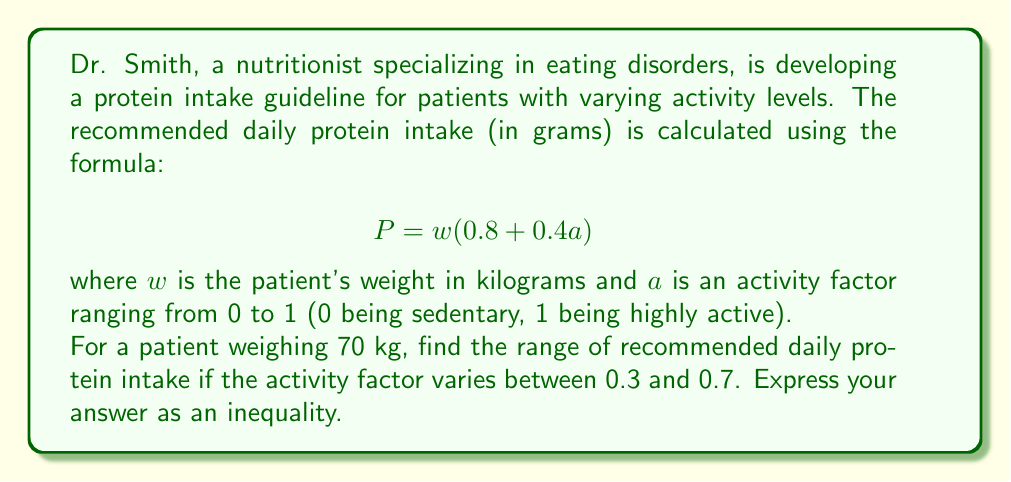Teach me how to tackle this problem. To solve this problem, we need to:

1. Substitute the given values into the formula for both the lower and upper bounds of the activity factor.
2. Calculate the protein intake for both cases.
3. Express the result as an inequality.

For the lower bound (a = 0.3):
$$ P_{low} = 70(0.8 + 0.4(0.3)) $$
$$ P_{low} = 70(0.8 + 0.12) $$
$$ P_{low} = 70(0.92) = 64.4 \text{ grams} $$

For the upper bound (a = 0.7):
$$ P_{high} = 70(0.8 + 0.4(0.7)) $$
$$ P_{high} = 70(0.8 + 0.28) $$
$$ P_{high} = 70(1.08) = 75.6 \text{ grams} $$

Therefore, the range of recommended daily protein intake can be expressed as the inequality:

$$ 64.4 \leq P \leq 75.6 $$

where $P$ is the recommended daily protein intake in grams.
Answer: $$ 64.4 \leq P \leq 75.6 $$ 